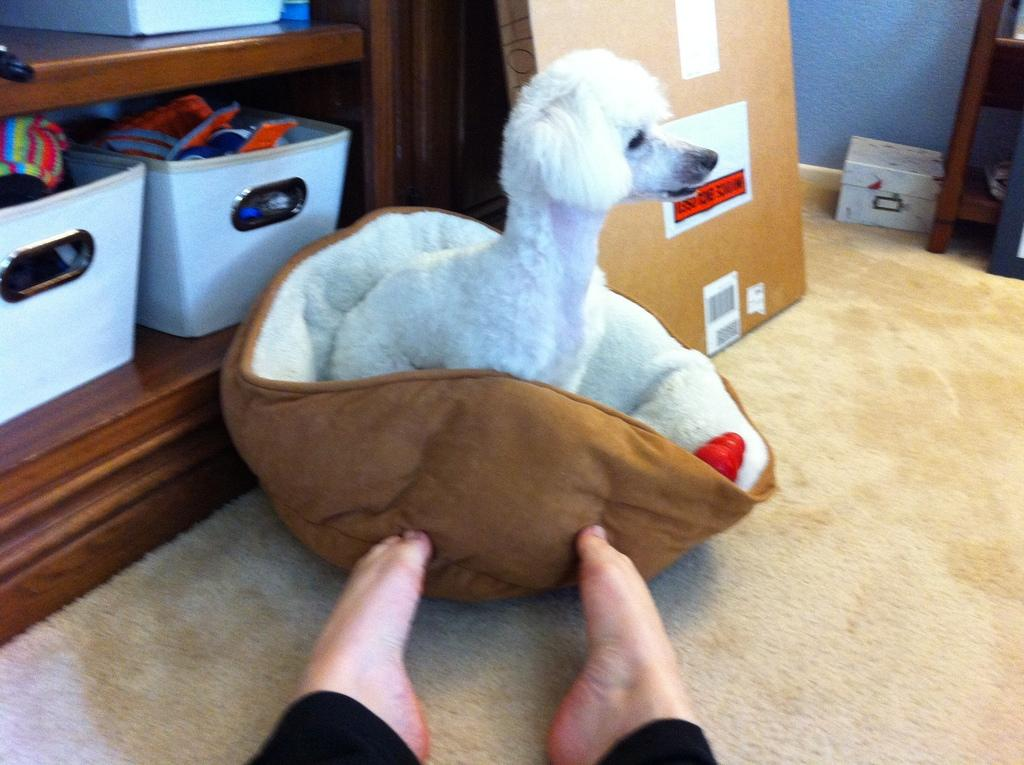What type of animal is in the image? There is a small puppy in the image. How is the puppy positioned in the image? The puppy is wrapped in a towel. Where is the towel-wrapped puppy located? The towel and puppy are placed on the carpet floor. What can be seen in the background of the image? There are baskets in the background of the image. What are the baskets used for? The baskets contain items. What type of tooth is visible in the image? There is no tooth visible in the image; it features a small puppy wrapped in a towel on the carpet floor. 